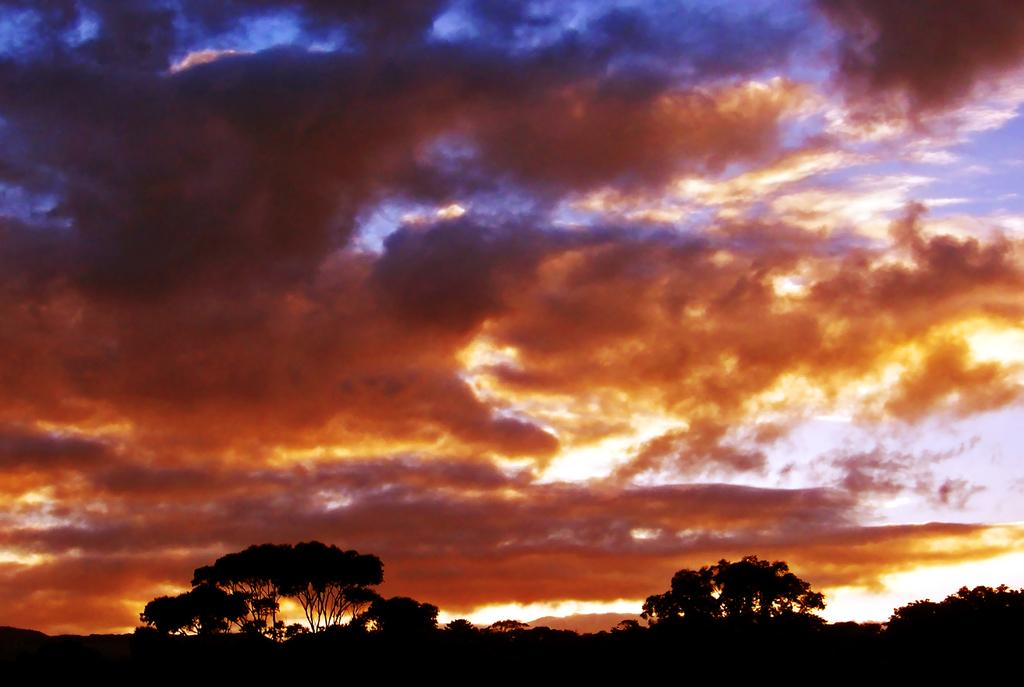What type of vegetation can be seen in the image? There are trees in the image. What is visible in the background of the image? The sky is visible in the image. What colors can be seen in the sky in the image? The sky has multiple colors, including blue, black, orange, and yellow. Can you tell me how many combs are being used by the fireman in the image? There is no fireman or comb present in the image. What type of weather can be seen in the image? The provided facts do not mention any specific weather conditions in the image. 